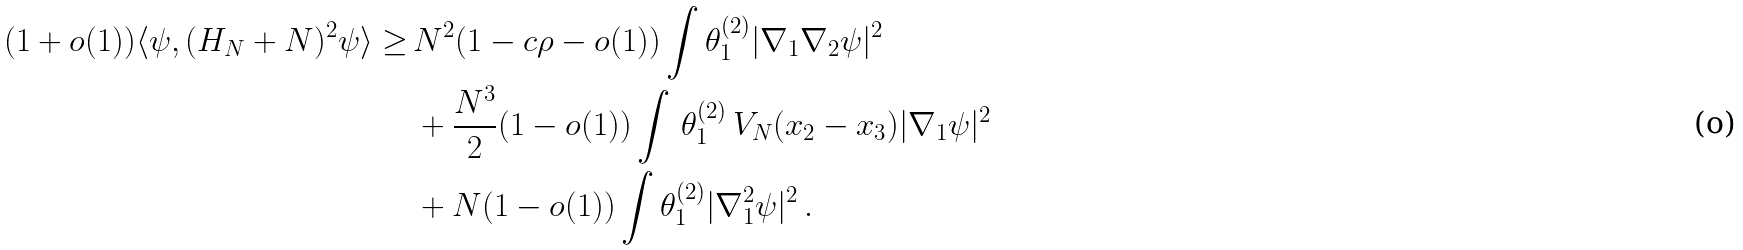Convert formula to latex. <formula><loc_0><loc_0><loc_500><loc_500>( 1 + o ( 1 ) ) \langle \psi , ( H _ { N } + N ) ^ { 2 } \psi \rangle \geq \, & N ^ { 2 } ( 1 - c \rho - o ( 1 ) ) \int \theta _ { 1 } ^ { ( 2 ) } | \nabla _ { 1 } \nabla _ { 2 } \psi | ^ { 2 } \\ & + \frac { N ^ { 3 } } { 2 } ( 1 - o ( 1 ) ) \int \, \theta _ { 1 } ^ { ( 2 ) } \, V _ { N } ( x _ { 2 } - x _ { 3 } ) | \nabla _ { 1 } \psi | ^ { 2 } \\ & + N ( 1 - o ( 1 ) ) \int \theta _ { 1 } ^ { ( 2 ) } | \nabla _ { 1 } ^ { 2 } \psi | ^ { 2 } \, .</formula> 